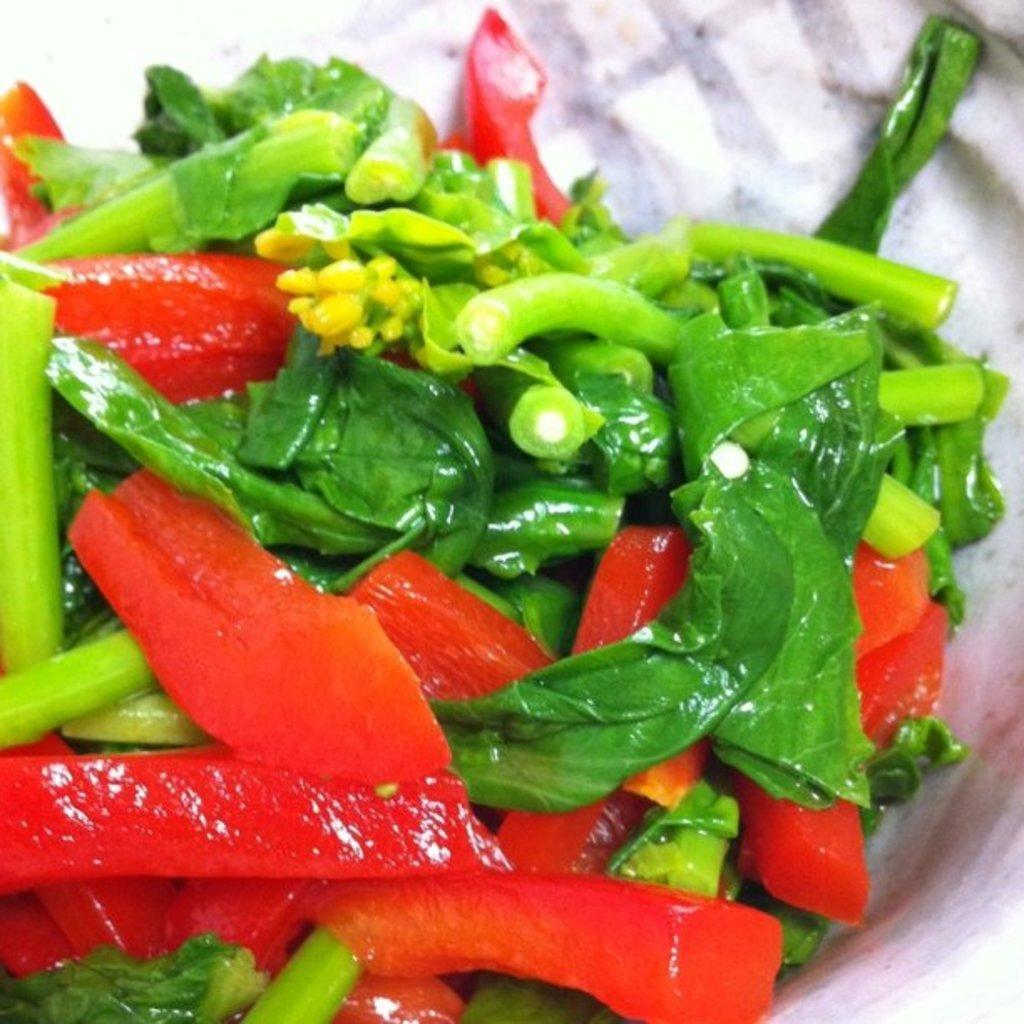What type of food can be seen in the image? There is some salad in the image. What specific ingredients are visible in the salad? There are green leafy vegetables in the image. What type of vegetables are present in the bowl? There are vegetables in the bowl. What type of brush is used to apply approval to the grain in the image? There is no brush, approval, or grain present in the image. 